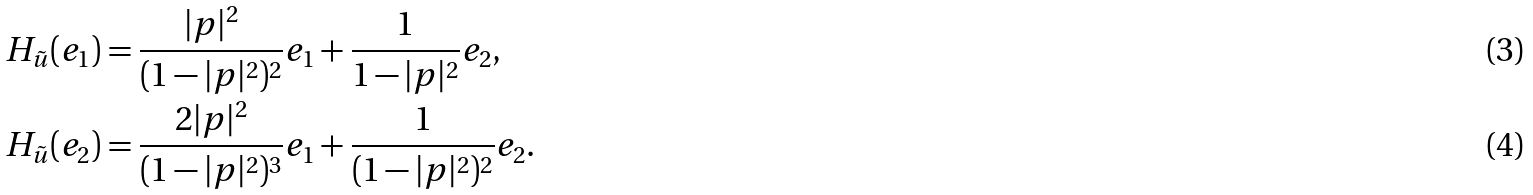Convert formula to latex. <formula><loc_0><loc_0><loc_500><loc_500>H _ { \tilde { u } } ( e _ { 1 } ) & = \frac { | p | ^ { 2 } } { ( 1 - | p | ^ { 2 } ) ^ { 2 } } e _ { 1 } + \frac { 1 } { 1 - | p | ^ { 2 } } e _ { 2 } , \\ H _ { \tilde { u } } ( e _ { 2 } ) & = \frac { 2 | p | ^ { 2 } } { ( 1 - | p | ^ { 2 } ) ^ { 3 } } e _ { 1 } + \frac { 1 } { ( 1 - | p | ^ { 2 } ) ^ { 2 } } e _ { 2 } .</formula> 